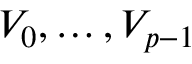Convert formula to latex. <formula><loc_0><loc_0><loc_500><loc_500>V _ { 0 } , \dots , V _ { p - 1 }</formula> 